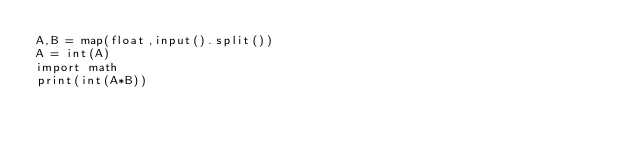<code> <loc_0><loc_0><loc_500><loc_500><_Python_>A,B = map(float,input().split())
A = int(A)
import math
print(int(A*B))</code> 